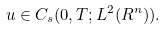<formula> <loc_0><loc_0><loc_500><loc_500>u \in C _ { s } ( 0 , T ; L ^ { 2 } ( R ^ { n } ) ) .</formula> 